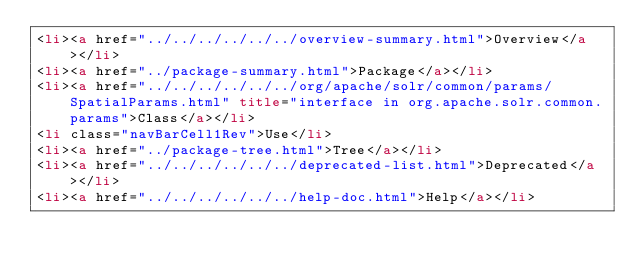Convert code to text. <code><loc_0><loc_0><loc_500><loc_500><_HTML_><li><a href="../../../../../../overview-summary.html">Overview</a></li>
<li><a href="../package-summary.html">Package</a></li>
<li><a href="../../../../../../org/apache/solr/common/params/SpatialParams.html" title="interface in org.apache.solr.common.params">Class</a></li>
<li class="navBarCell1Rev">Use</li>
<li><a href="../package-tree.html">Tree</a></li>
<li><a href="../../../../../../deprecated-list.html">Deprecated</a></li>
<li><a href="../../../../../../help-doc.html">Help</a></li></code> 